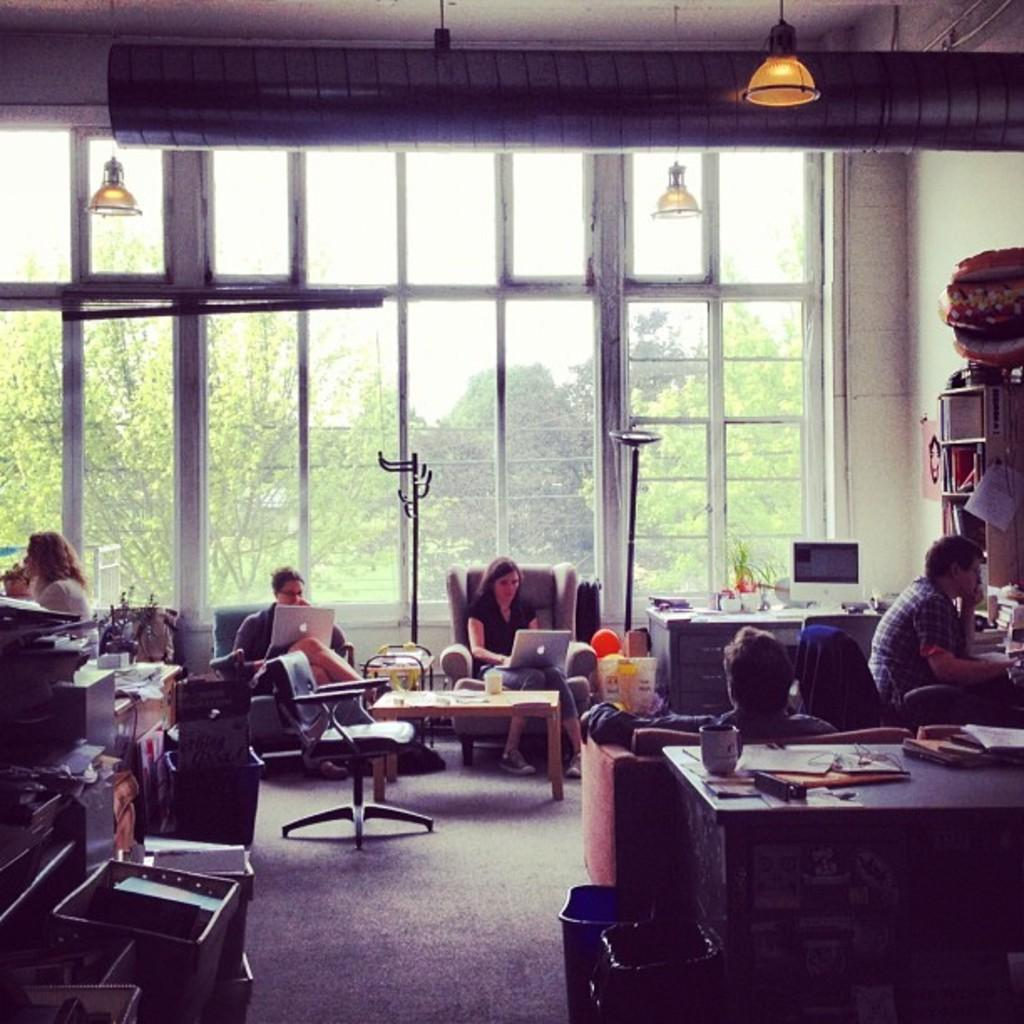How many people are sitting on the sofa in the image? There are two persons sitting on the sofa in the image. What is one of the persons on the sofa doing? One of the persons on the sofa is operating a MacBook. How many other people are sitting in front of the sofa? There are two other persons sitting in front of the sofa. What is the gender of the person sitting beside the two persons in front of the sofa? The person sitting beside the two persons in front of the sofa is a woman. What type of door can be seen in the image? There is no door visible in the image. How much dust is present on the MacBook in the image? The image does not provide information about the presence of dust on the MacBook. 